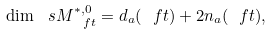<formula> <loc_0><loc_0><loc_500><loc_500>\dim \ s M _ { \ f t } ^ { * , 0 } = d _ { a } ( \ f t ) + 2 n _ { a } ( \ f t ) ,</formula> 